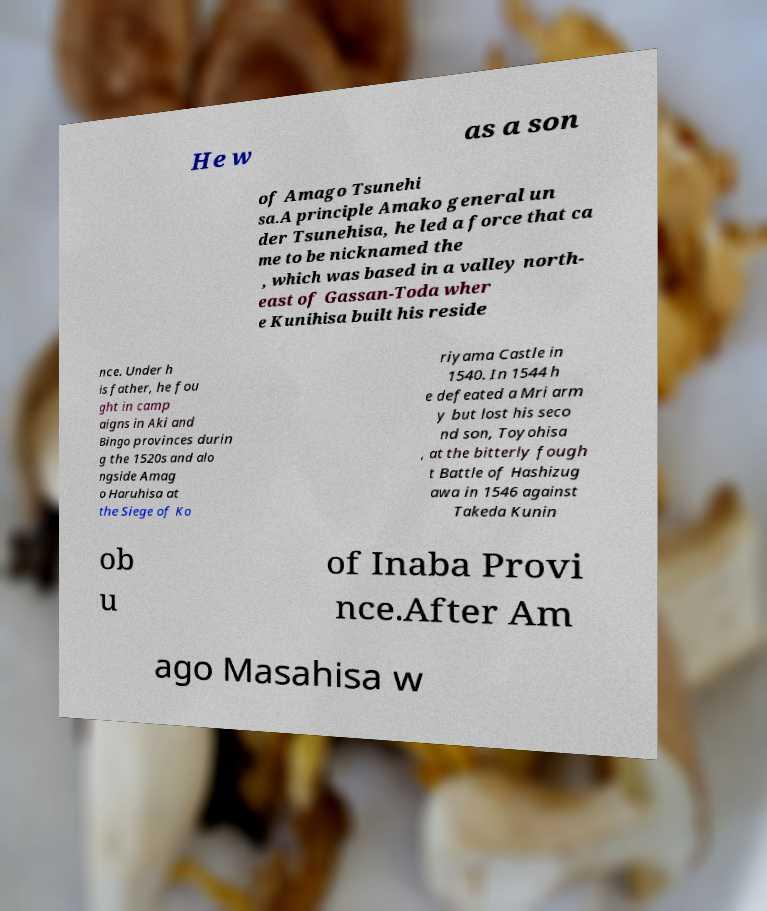Could you extract and type out the text from this image? He w as a son of Amago Tsunehi sa.A principle Amako general un der Tsunehisa, he led a force that ca me to be nicknamed the , which was based in a valley north- east of Gassan-Toda wher e Kunihisa built his reside nce. Under h is father, he fou ght in camp aigns in Aki and Bingo provinces durin g the 1520s and alo ngside Amag o Haruhisa at the Siege of Ko riyama Castle in 1540. In 1544 h e defeated a Mri arm y but lost his seco nd son, Toyohisa , at the bitterly fough t Battle of Hashizug awa in 1546 against Takeda Kunin ob u of Inaba Provi nce.After Am ago Masahisa w 